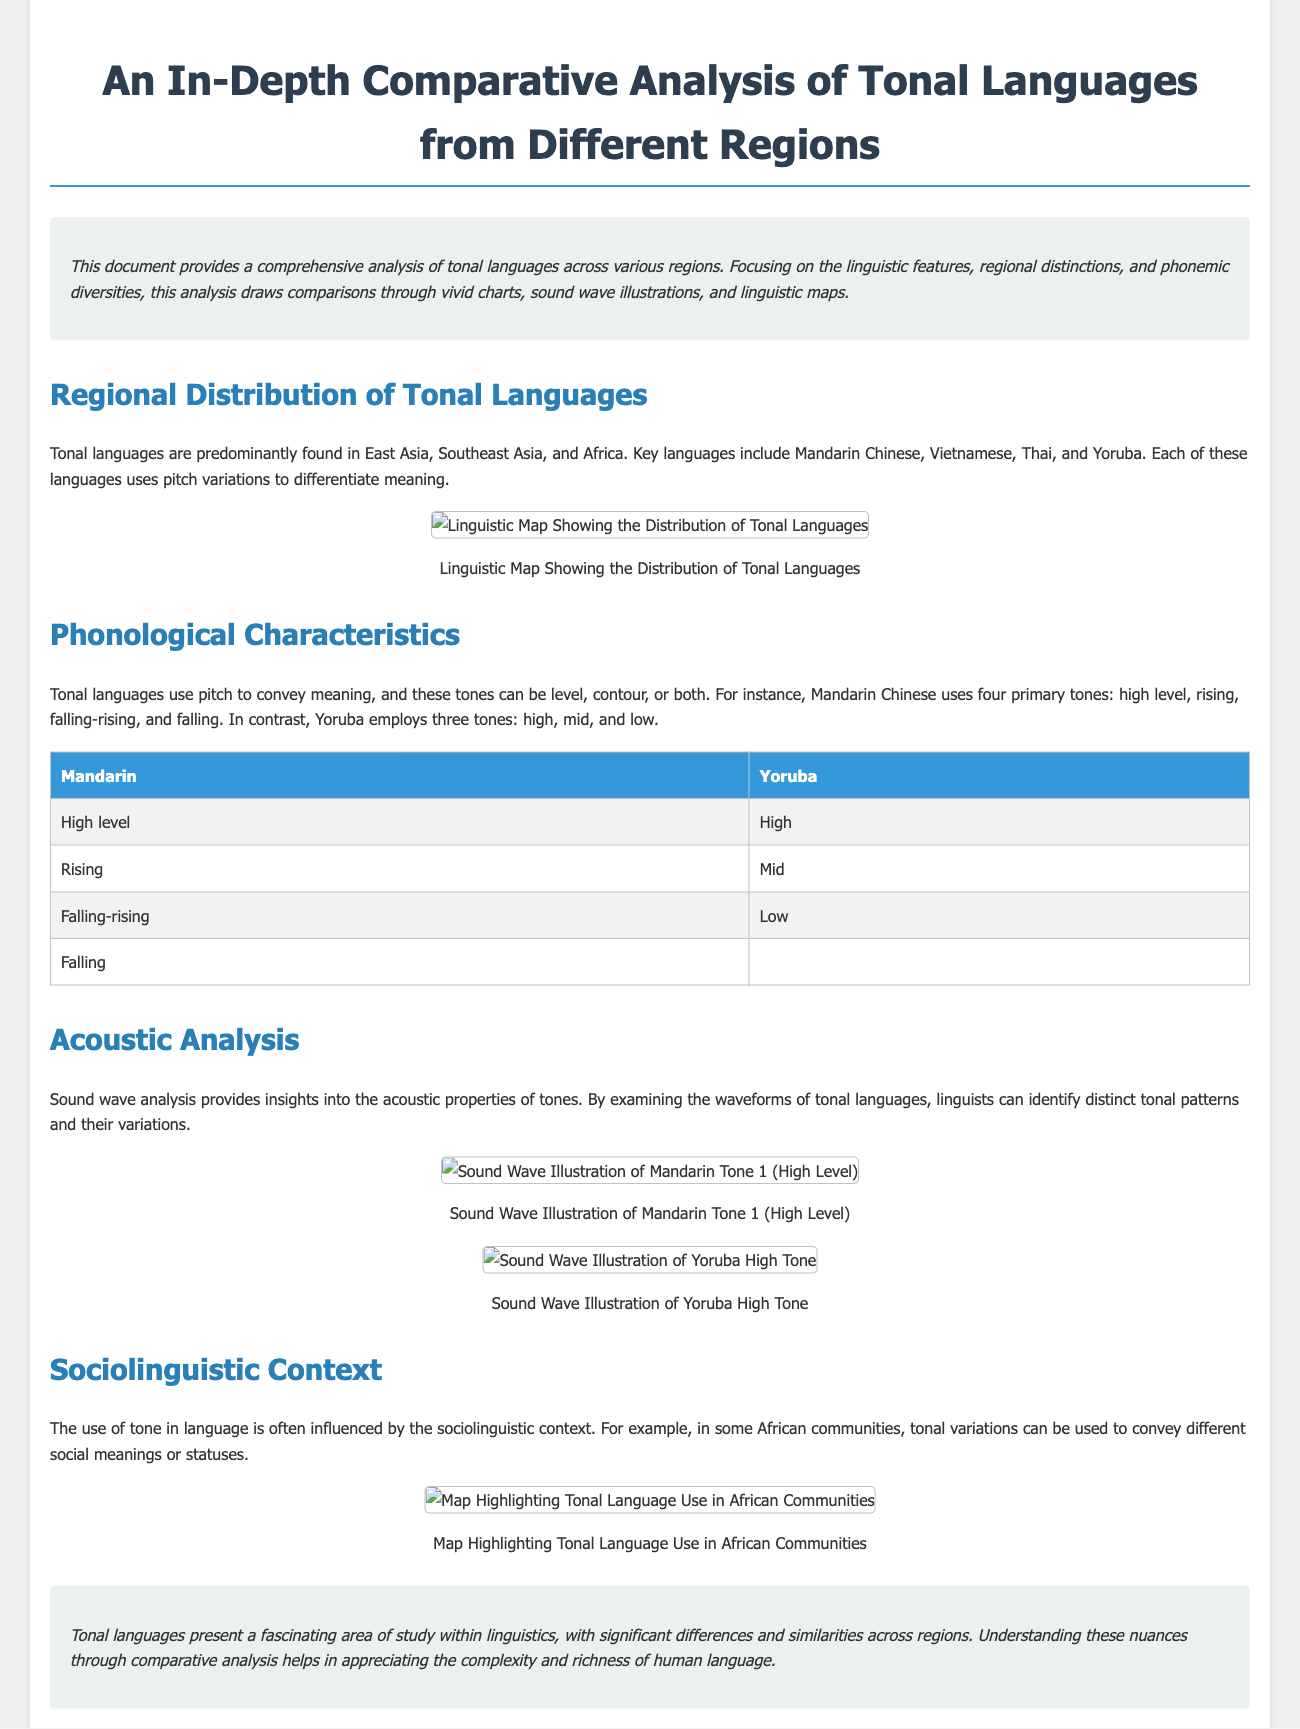What languages are predominantly tonal? The document mentions that tonal languages are primarily found in East Asia, Southeast Asia, and Africa, with examples including Mandarin Chinese, Vietnamese, Thai, and Yoruba.
Answer: Mandarin Chinese, Vietnamese, Thai, Yoruba How many primary tones does Mandarin Chinese have? The document specifies that Mandarin Chinese uses four primary tones, which are high level, rising, falling-rising, and falling.
Answer: Four What is the high tone in Yoruba described as? The document states that Yoruba employs three tones, and one of them is referred to as high.
Answer: High What unique linguistic analysis technique is mentioned in the document? The document describes sound wave analysis as a method to gain insights into the acoustic properties of tones in tonal languages.
Answer: Sound wave analysis What is the purpose of comparing tonal languages in this document? The document explains that comparative analysis helps appreciate the complexity and richness of human language through understanding the differences and similarities across regions.
Answer: Understanding differences and similarities Which geographic regions are highlighted for tonal languages? Key regions identified in the document where tonal languages are predominantly found include East Asia, Southeast Asia, and Africa.
Answer: East Asia, Southeast Asia, Africa How many tones does Yoruba utilize? The document notes that Yoruba employs three tones: high, mid, and low.
Answer: Three What type of map is used to illustrate tonal language distribution? The document references a linguistic map to show the distribution of tonal languages across regions.
Answer: Linguistic map 